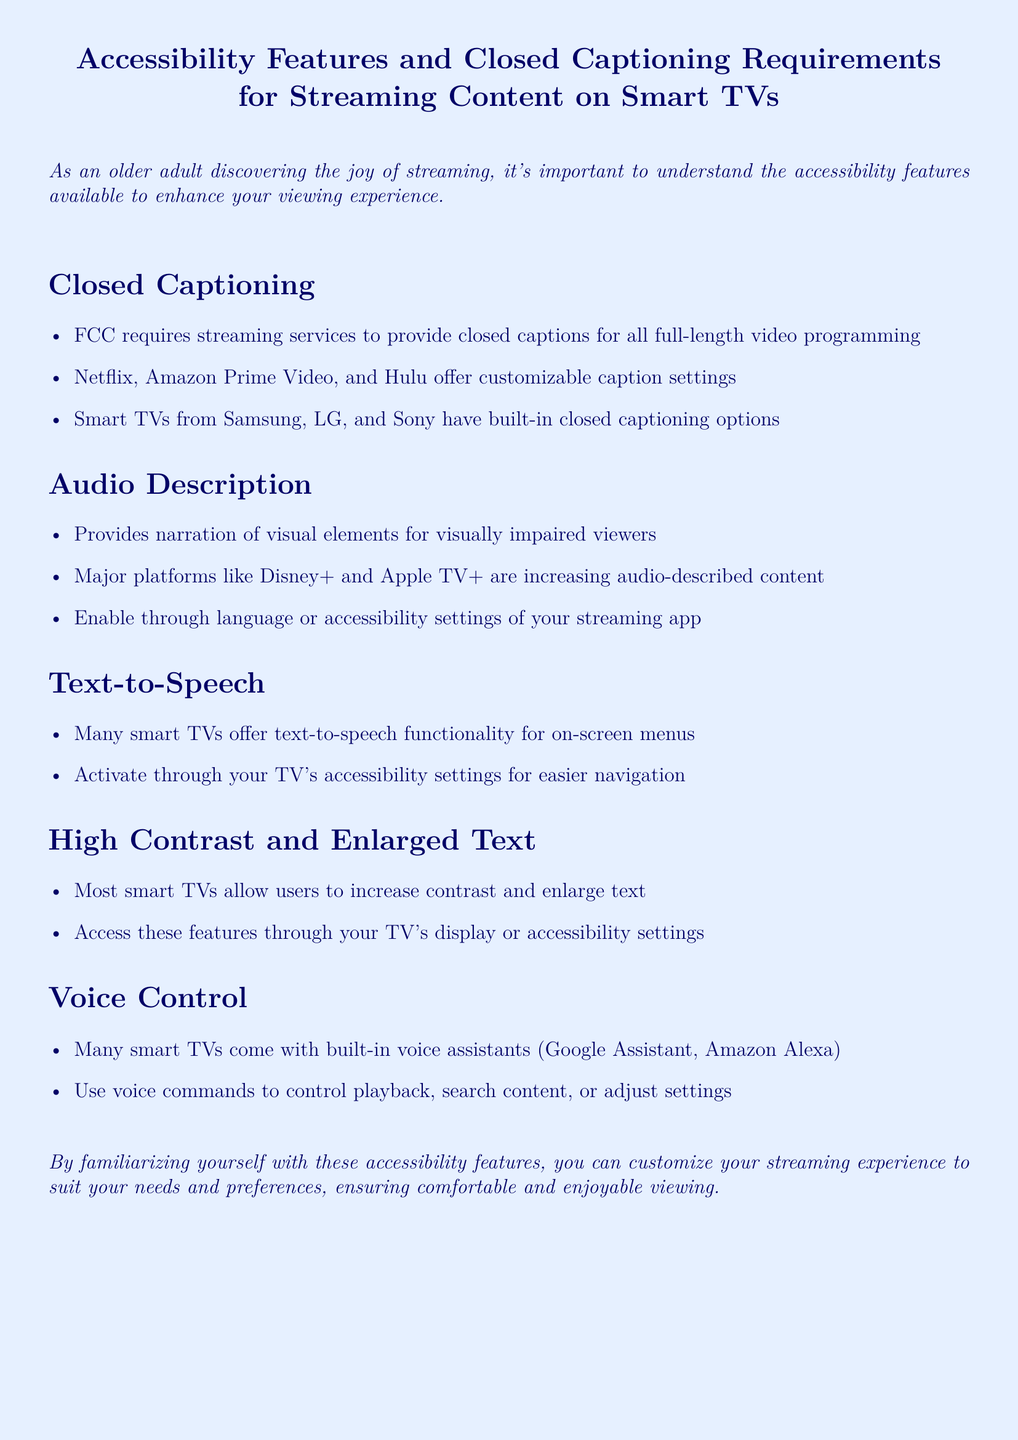What is the FCC requirement for streaming services? The FCC requires streaming services to provide closed captions for all full-length video programming.
Answer: Closed captions Which platforms offer customizable caption settings? Netflix, Amazon Prime Video, and Hulu offer customizable caption settings.
Answer: Netflix, Amazon Prime Video, Hulu What accessibility feature helps visually impaired viewers? Audio description provides narration of visual elements for visually impaired viewers.
Answer: Audio description Which smart TV brands have built-in closed captioning options? Smart TVs from Samsung, LG, and Sony have built-in closed captioning options.
Answer: Samsung, LG, Sony How can you enable audio description on streaming apps? Enable through language or accessibility settings of your streaming app.
Answer: Language or accessibility settings What technology allows for on-screen menu navigation? Many smart TVs offer text-to-speech functionality for on-screen menus.
Answer: Text-to-speech Which voice assistants are mentioned in the document? Google Assistant and Amazon Alexa are mentioned as built-in voice assistants.
Answer: Google Assistant, Amazon Alexa How can users increase text size on smart TVs? Most smart TVs allow users to increase contrast and enlarge text through display or accessibility settings.
Answer: Display or accessibility settings What is one benefit of familiarizing yourself with accessibility features? Familiarizing yourself with these features ensures comfortable and enjoyable viewing.
Answer: Comfortable and enjoyable viewing 